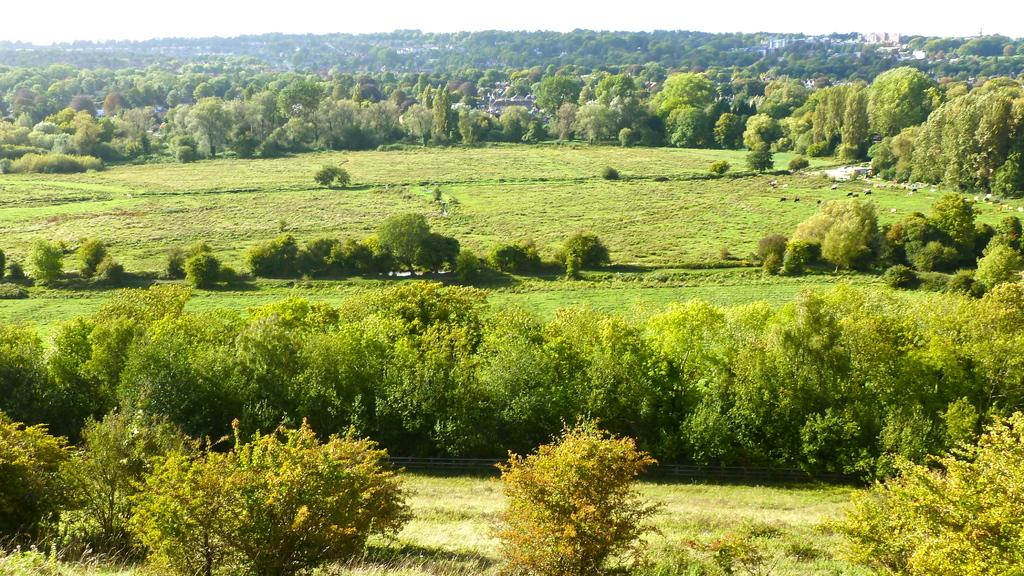What type of vegetation is present in the image? There are trees in the image. What else can be seen on the ground in the image? There is grass in the image. Are there any man-made structures visible in the image? Yes, there are buildings in the image. What type of toy can be seen hanging from the trees in the image? There is no toy present in the image; it only features trees, grass, and buildings. 